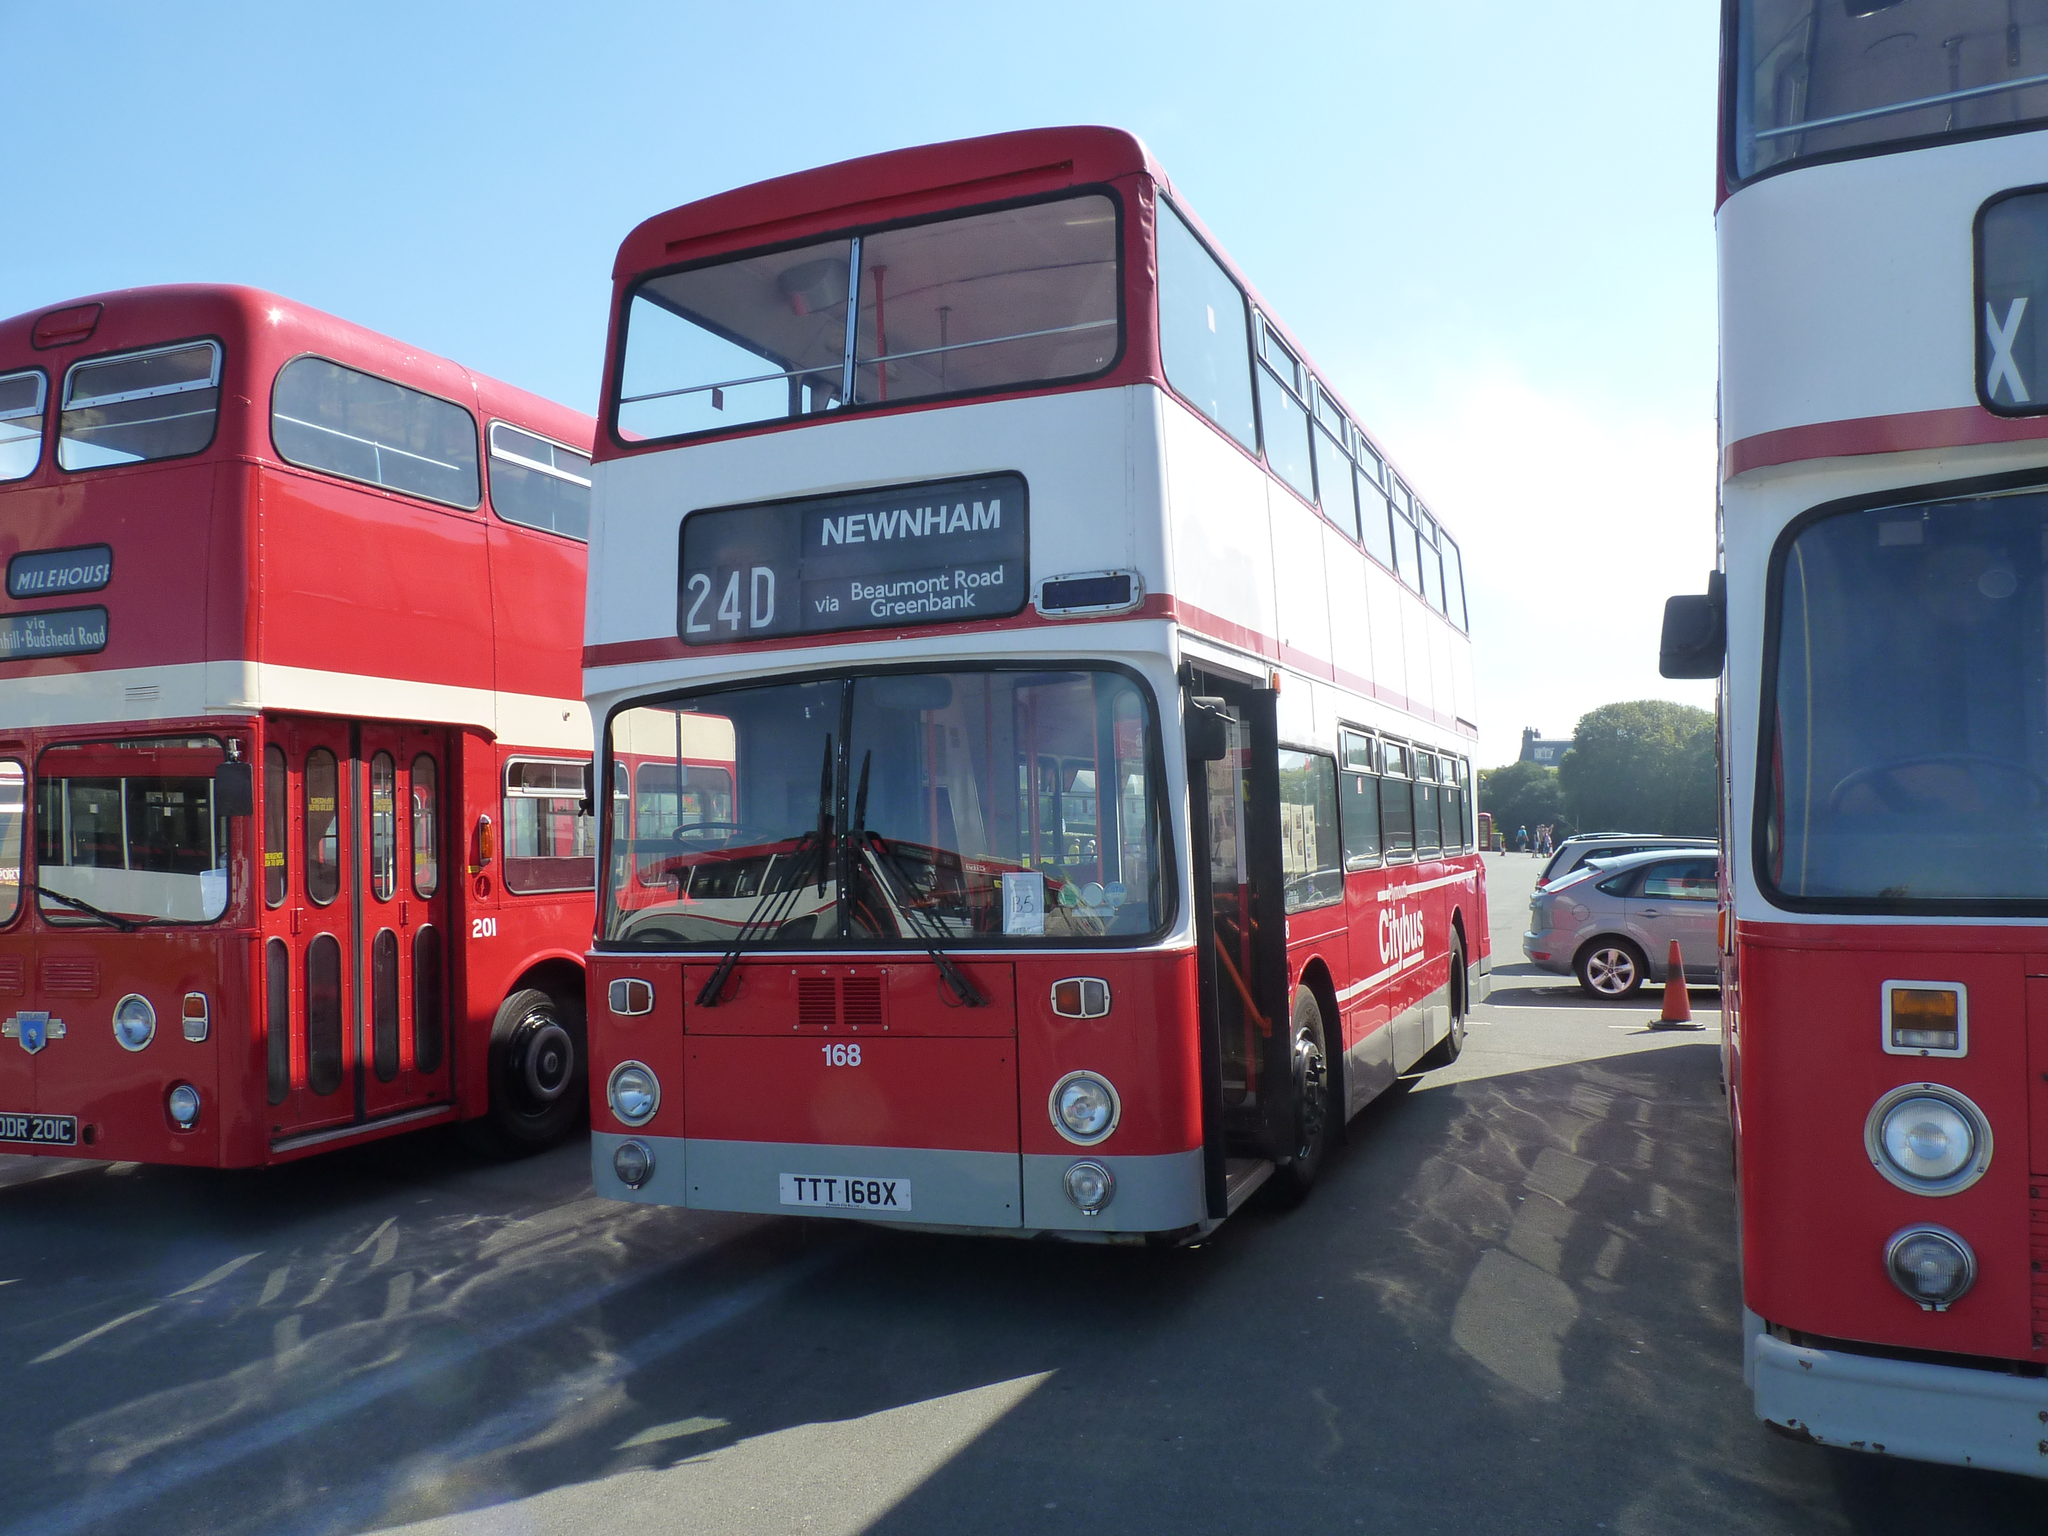Provide a one-sentence caption for the provided image. A Newham bus with the number 24D sits between two other buses. 